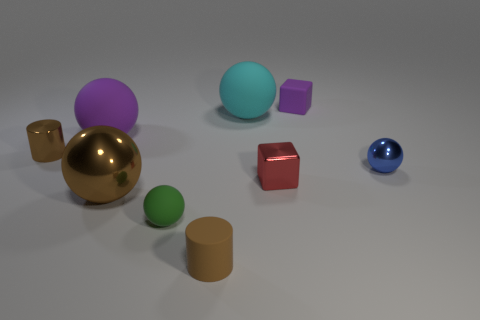Do the tiny ball on the right side of the big cyan rubber ball and the tiny ball to the left of the small blue thing have the same material?
Ensure brevity in your answer.  No. There is a purple object that is to the left of the rubber block; is its shape the same as the large object in front of the blue ball?
Offer a very short reply. Yes. Is the number of purple matte spheres in front of the big purple object less than the number of big spheres?
Provide a succinct answer. Yes. What number of big rubber spheres are the same color as the small matte block?
Your answer should be compact. 1. How big is the purple matte object behind the purple matte ball?
Keep it short and to the point. Small. The tiny brown thing that is on the right side of the tiny brown thing behind the tiny brown cylinder in front of the tiny brown metallic cylinder is what shape?
Provide a short and direct response. Cylinder. What is the shape of the object that is in front of the big cyan thing and right of the metal block?
Ensure brevity in your answer.  Sphere. Is there a purple matte block of the same size as the brown matte object?
Your answer should be compact. Yes. There is a big matte object that is behind the large purple matte sphere; does it have the same shape as the big shiny object?
Offer a very short reply. Yes. Is the shape of the large brown object the same as the cyan object?
Your answer should be compact. Yes. 